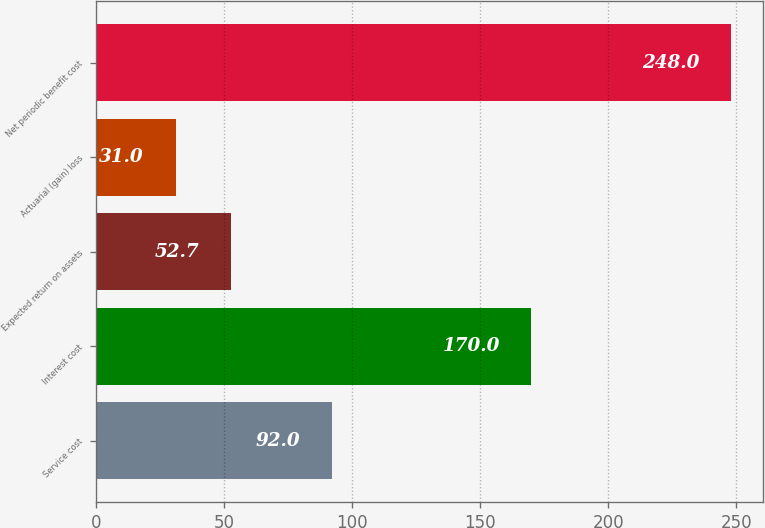Convert chart. <chart><loc_0><loc_0><loc_500><loc_500><bar_chart><fcel>Service cost<fcel>Interest cost<fcel>Expected return on assets<fcel>Actuarial (gain) loss<fcel>Net periodic benefit cost<nl><fcel>92<fcel>170<fcel>52.7<fcel>31<fcel>248<nl></chart> 